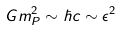<formula> <loc_0><loc_0><loc_500><loc_500>G m _ { P } ^ { 2 } \sim \hbar { c } \sim \epsilon ^ { 2 }</formula> 